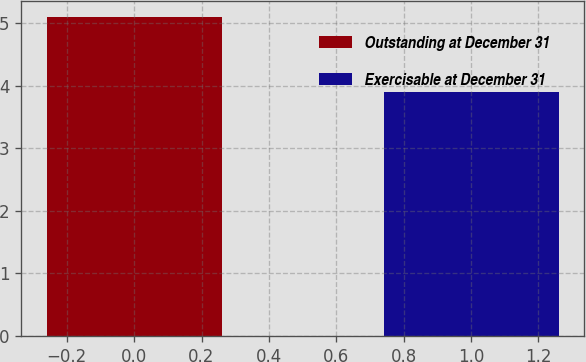<chart> <loc_0><loc_0><loc_500><loc_500><bar_chart><fcel>Outstanding at December 31<fcel>Exercisable at December 31<nl><fcel>5.1<fcel>3.9<nl></chart> 